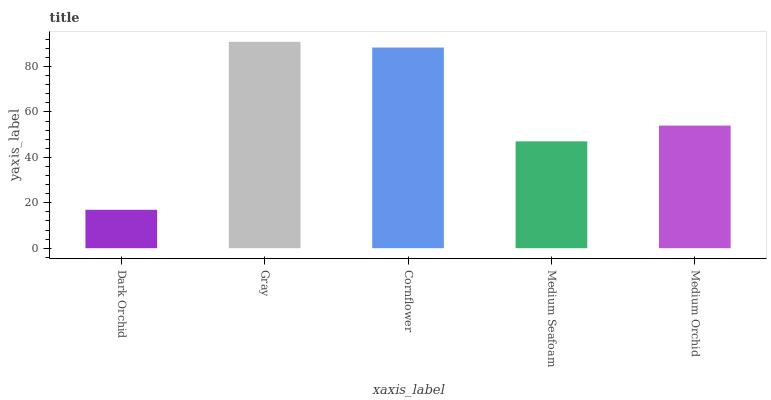Is Dark Orchid the minimum?
Answer yes or no. Yes. Is Gray the maximum?
Answer yes or no. Yes. Is Cornflower the minimum?
Answer yes or no. No. Is Cornflower the maximum?
Answer yes or no. No. Is Gray greater than Cornflower?
Answer yes or no. Yes. Is Cornflower less than Gray?
Answer yes or no. Yes. Is Cornflower greater than Gray?
Answer yes or no. No. Is Gray less than Cornflower?
Answer yes or no. No. Is Medium Orchid the high median?
Answer yes or no. Yes. Is Medium Orchid the low median?
Answer yes or no. Yes. Is Cornflower the high median?
Answer yes or no. No. Is Dark Orchid the low median?
Answer yes or no. No. 